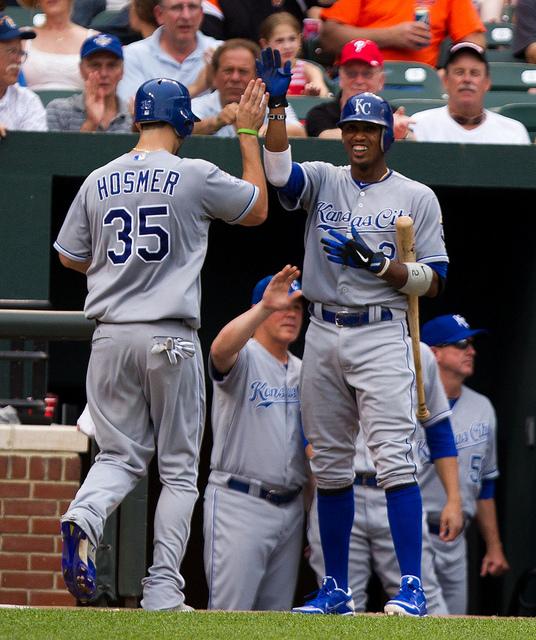Is the man waiting to hit the ball?
Concise answer only. No. Are the players in the middle of a game?
Answer briefly. Yes. What brand are the baseball player's shoes?
Concise answer only. Nike. What team is this?
Be succinct. Kansas city. What sport is being played?
Give a very brief answer. Baseball. What is the color of his socks?
Concise answer only. Blue. Does the fan have a hat on?
Answer briefly. Yes. What is the number to the left?
Short answer required. 35. 